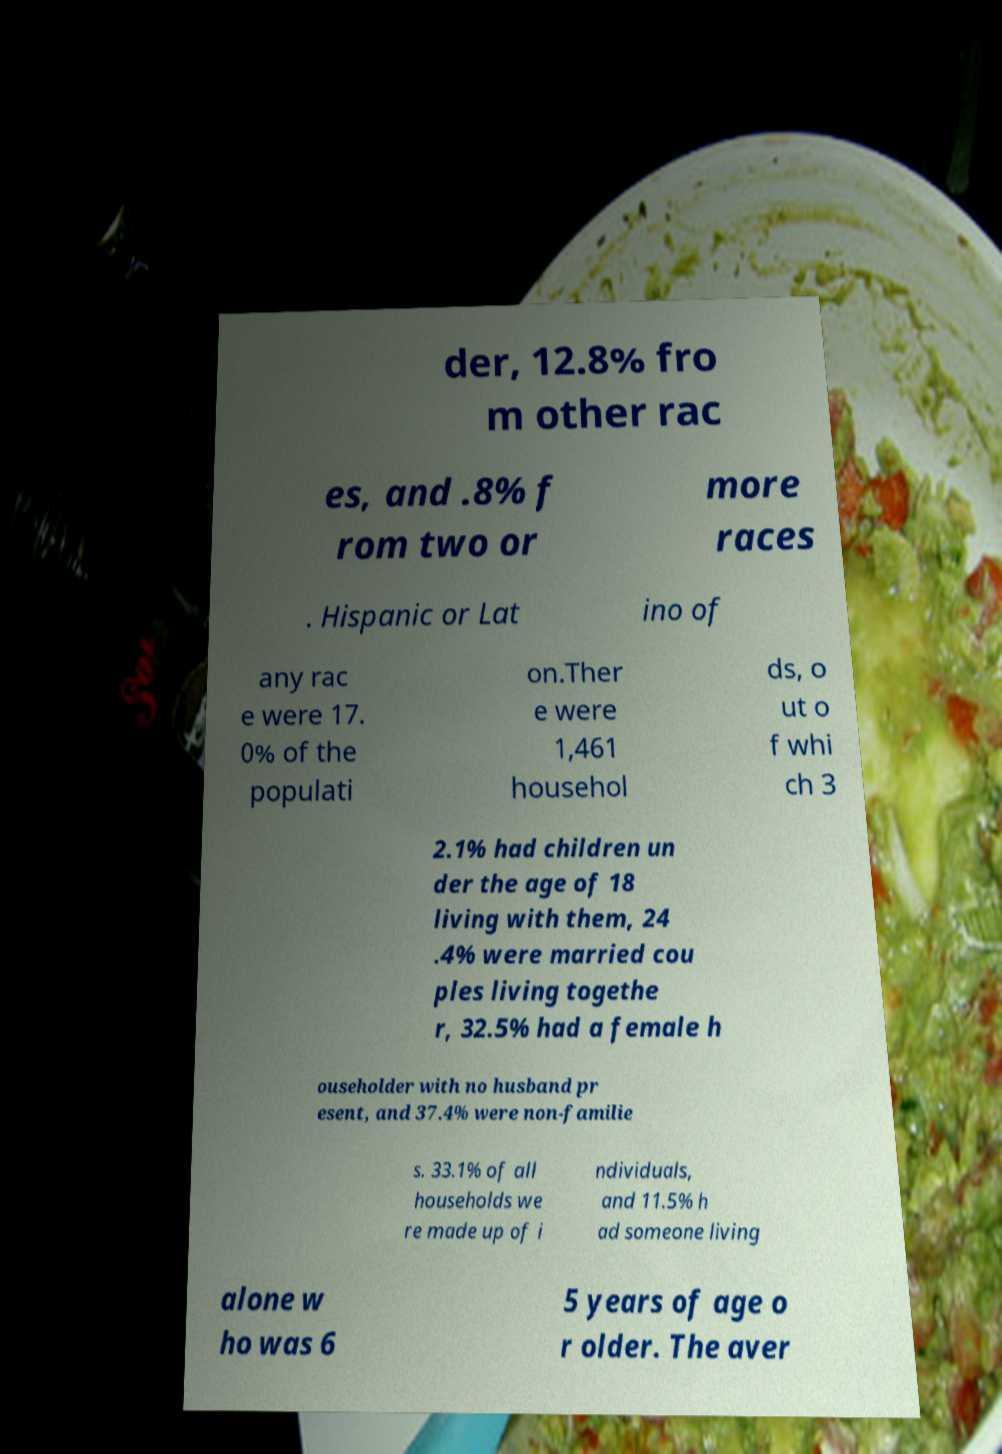For documentation purposes, I need the text within this image transcribed. Could you provide that? der, 12.8% fro m other rac es, and .8% f rom two or more races . Hispanic or Lat ino of any rac e were 17. 0% of the populati on.Ther e were 1,461 househol ds, o ut o f whi ch 3 2.1% had children un der the age of 18 living with them, 24 .4% were married cou ples living togethe r, 32.5% had a female h ouseholder with no husband pr esent, and 37.4% were non-familie s. 33.1% of all households we re made up of i ndividuals, and 11.5% h ad someone living alone w ho was 6 5 years of age o r older. The aver 